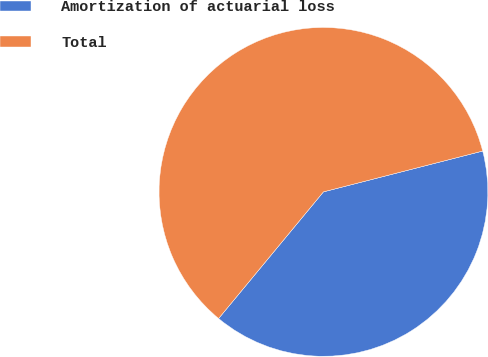Convert chart. <chart><loc_0><loc_0><loc_500><loc_500><pie_chart><fcel>Amortization of actuarial loss<fcel>Total<nl><fcel>40.0%<fcel>60.0%<nl></chart> 